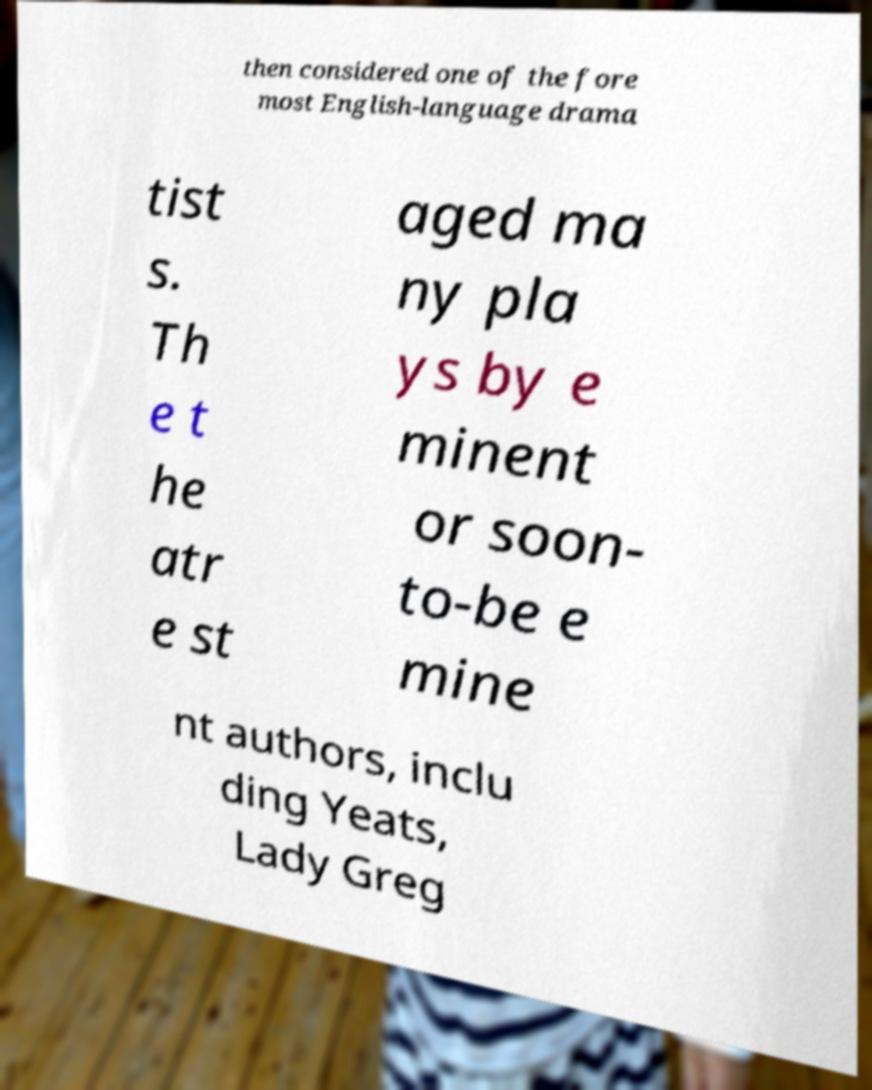Please read and relay the text visible in this image. What does it say? then considered one of the fore most English-language drama tist s. Th e t he atr e st aged ma ny pla ys by e minent or soon- to-be e mine nt authors, inclu ding Yeats, Lady Greg 